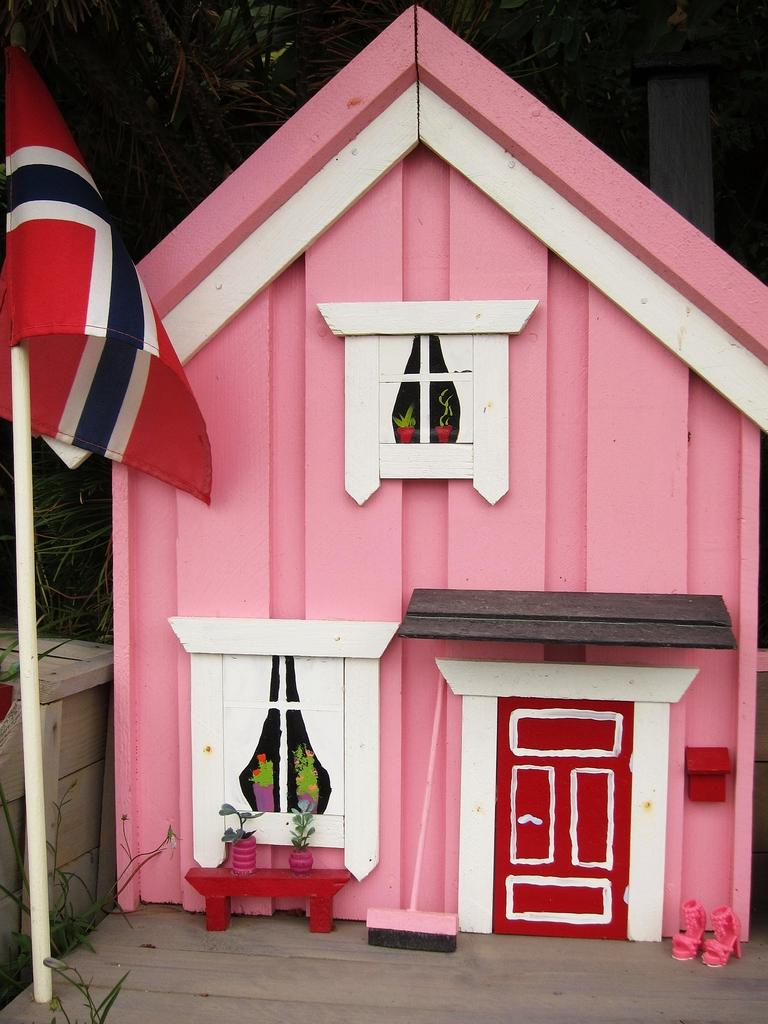What is depicted in the foreground of the image? There is a depiction of a house in the foreground of the image. What else can be seen in the foreground of the image? There are flower pots in the foreground of the image. Where is the flag located in the image? The flag is on the left side of the image. What can be seen in the background of the image? There is greenery in the background of the image. Can you describe the bear that is pulling the carriage in the image? There is no bear or carriage present in the image. What type of sun is visible in the image? There is no sun visible in the image; only a flag, a house, flower pots, and greenery are present. 